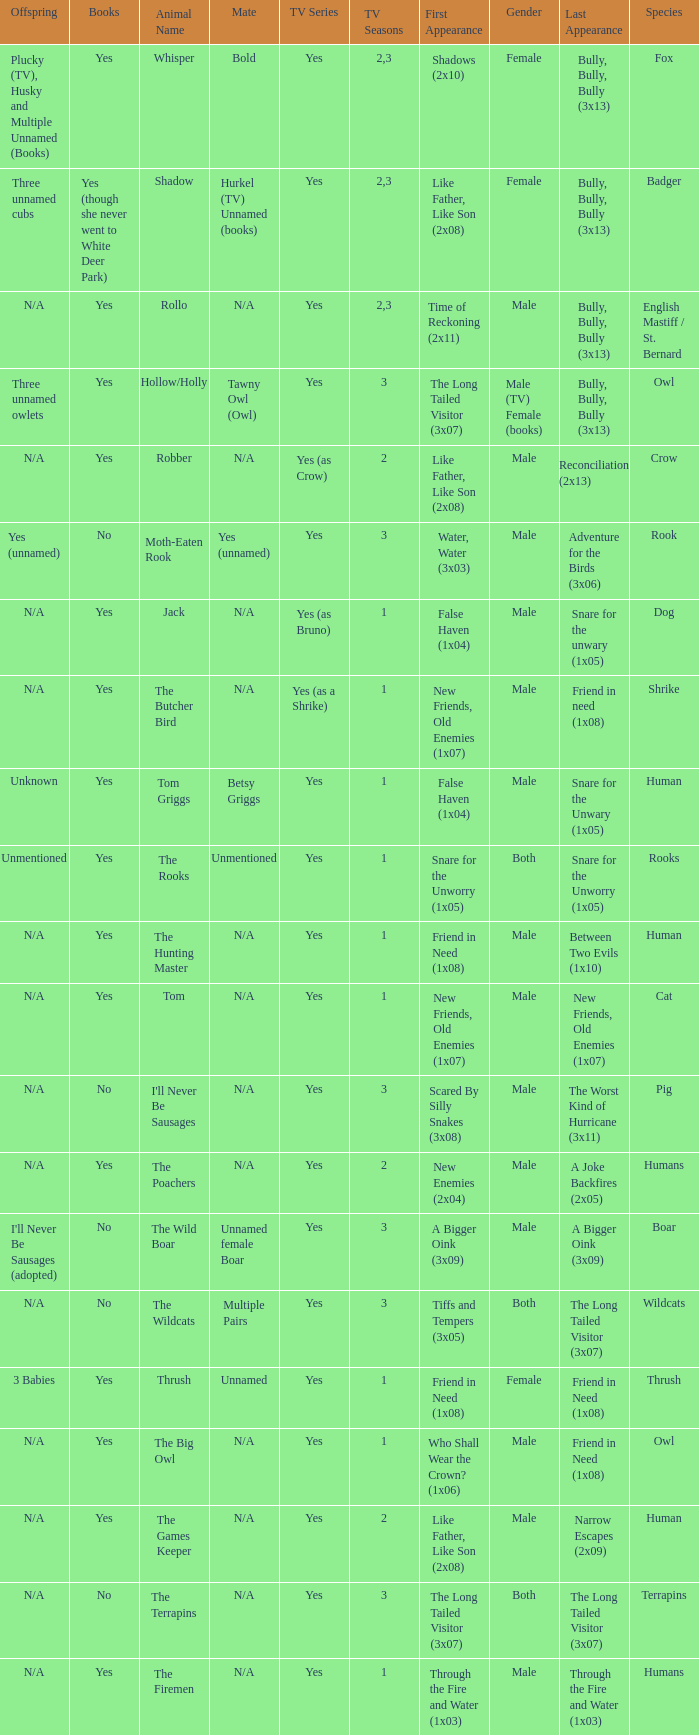What show has a boar? Yes. 